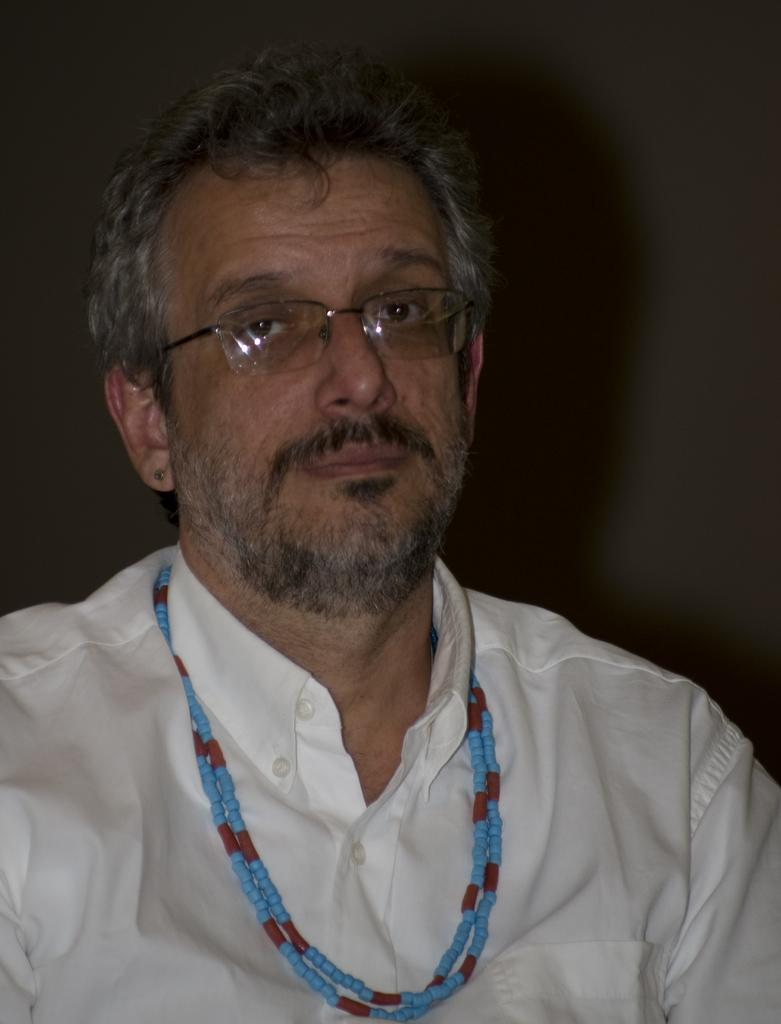What is the main subject of the picture? The main subject of the picture is a person. Can you describe the person's appearance? The person is wearing spectacles and jewelry. What type of print can be seen on the goat in the image? There is no goat present in the image, so there is no print to observe. 